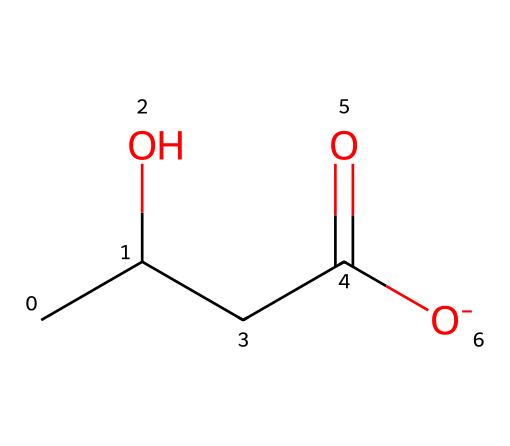What is the name of this chemical? The SMILES representation indicates that this compound is beta-hydroxybutyrate, a ketone body. The 'CC(O)CC(=O)[O-]' notation describes its structure, revealing it to be a derivative of butyric acid with a hydroxyl group.
Answer: beta-hydroxybutyrate How many carbon atoms are present in beta-hydroxybutyrate? By examining the SMILES string 'CC(O)CC(=O)[O-]', we can count the 'C's that indicate carbon atoms. There are four total carbon atoms in the structure.
Answer: 4 What functional groups are present in beta-hydroxybutyrate? In the chemical structure, we can identify a hydroxyl group (-OH) indicated by 'O' and a carboxylate group (-COO-) seen in '=O' and '[O-]'. Therefore, both groups are present.
Answer: hydroxyl, carboxylate How many oxygen atoms are in this ketone body? Looking at the SMILES 'CC(O)CC(=O)[O-]', there are two distinct oxygen atoms represented, one in the hydroxyl group and one in the carboxylate part.
Answer: 2 Which part of this chemical indicates that it is a ketone? The characteristic feature of a ketone is the carbonyl group, denoted by the '(=O)' in the SMILES representation. This part is part of the structure making it a ketone body.
Answer: carbonyl group What is the charge of the carboxylate group in this ketone? The '[O-]' in the SMILES indicates that the oxygen in the carboxylate group carries a negative charge, confirming its deprotonated form.
Answer: negative Is beta-hydroxybutyrate produced during fasting or after high carbohydrate intake? Beta-hydroxybutyrate is primarily produced during fasting or ketogenic states when carbohydrate intake is low, leading to ketogenesis.
Answer: fasting 